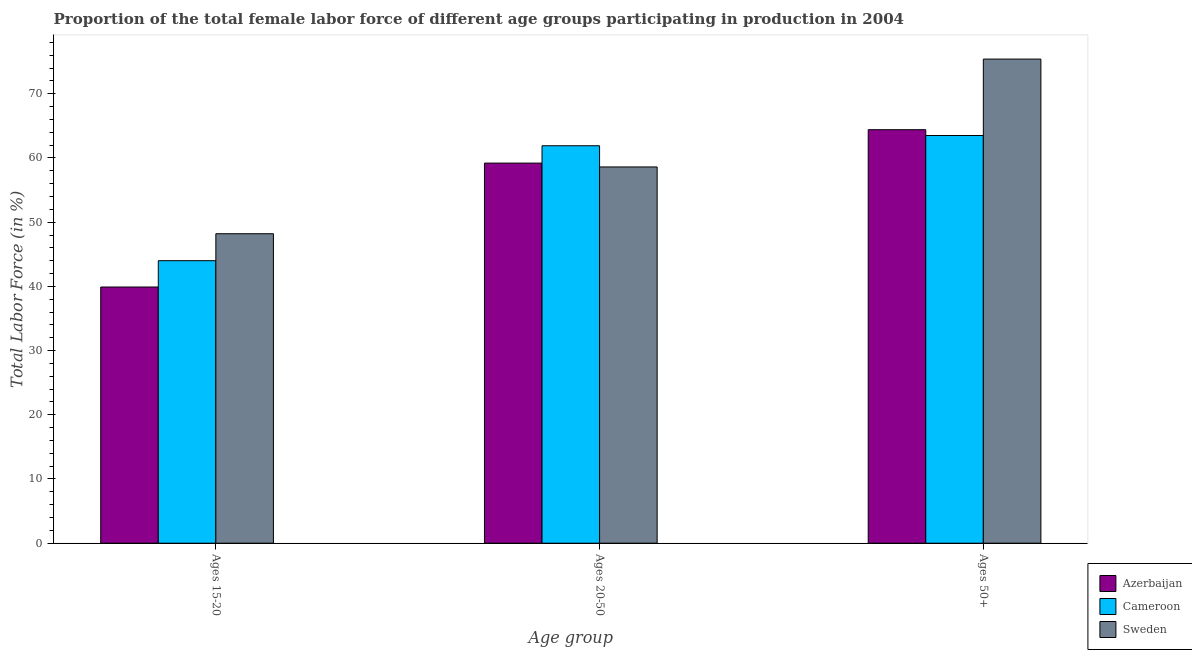What is the label of the 1st group of bars from the left?
Your response must be concise. Ages 15-20. What is the percentage of female labor force above age 50 in Sweden?
Ensure brevity in your answer.  75.4. Across all countries, what is the maximum percentage of female labor force within the age group 20-50?
Your answer should be compact. 61.9. Across all countries, what is the minimum percentage of female labor force within the age group 15-20?
Provide a succinct answer. 39.9. In which country was the percentage of female labor force above age 50 minimum?
Offer a terse response. Cameroon. What is the total percentage of female labor force within the age group 20-50 in the graph?
Your response must be concise. 179.7. What is the difference between the percentage of female labor force within the age group 20-50 in Cameroon and that in Azerbaijan?
Your answer should be very brief. 2.7. What is the average percentage of female labor force above age 50 per country?
Your answer should be very brief. 67.77. What is the difference between the percentage of female labor force within the age group 20-50 and percentage of female labor force above age 50 in Azerbaijan?
Your response must be concise. -5.2. What is the ratio of the percentage of female labor force within the age group 15-20 in Sweden to that in Cameroon?
Give a very brief answer. 1.1. Is the percentage of female labor force within the age group 20-50 in Cameroon less than that in Azerbaijan?
Make the answer very short. No. Is the difference between the percentage of female labor force within the age group 15-20 in Sweden and Cameroon greater than the difference between the percentage of female labor force within the age group 20-50 in Sweden and Cameroon?
Keep it short and to the point. Yes. What is the difference between the highest and the second highest percentage of female labor force above age 50?
Provide a short and direct response. 11. What is the difference between the highest and the lowest percentage of female labor force above age 50?
Offer a terse response. 11.9. What does the 2nd bar from the right in Ages 50+ represents?
Your answer should be compact. Cameroon. Is it the case that in every country, the sum of the percentage of female labor force within the age group 15-20 and percentage of female labor force within the age group 20-50 is greater than the percentage of female labor force above age 50?
Provide a succinct answer. Yes. How many bars are there?
Give a very brief answer. 9. Are all the bars in the graph horizontal?
Give a very brief answer. No. How many countries are there in the graph?
Your answer should be very brief. 3. Does the graph contain any zero values?
Your answer should be very brief. No. Where does the legend appear in the graph?
Your answer should be compact. Bottom right. How are the legend labels stacked?
Provide a succinct answer. Vertical. What is the title of the graph?
Keep it short and to the point. Proportion of the total female labor force of different age groups participating in production in 2004. Does "Greece" appear as one of the legend labels in the graph?
Provide a succinct answer. No. What is the label or title of the X-axis?
Your answer should be very brief. Age group. What is the Total Labor Force (in %) of Azerbaijan in Ages 15-20?
Give a very brief answer. 39.9. What is the Total Labor Force (in %) of Sweden in Ages 15-20?
Provide a succinct answer. 48.2. What is the Total Labor Force (in %) in Azerbaijan in Ages 20-50?
Offer a terse response. 59.2. What is the Total Labor Force (in %) in Cameroon in Ages 20-50?
Give a very brief answer. 61.9. What is the Total Labor Force (in %) of Sweden in Ages 20-50?
Offer a terse response. 58.6. What is the Total Labor Force (in %) in Azerbaijan in Ages 50+?
Give a very brief answer. 64.4. What is the Total Labor Force (in %) in Cameroon in Ages 50+?
Offer a terse response. 63.5. What is the Total Labor Force (in %) of Sweden in Ages 50+?
Give a very brief answer. 75.4. Across all Age group, what is the maximum Total Labor Force (in %) in Azerbaijan?
Ensure brevity in your answer.  64.4. Across all Age group, what is the maximum Total Labor Force (in %) in Cameroon?
Make the answer very short. 63.5. Across all Age group, what is the maximum Total Labor Force (in %) in Sweden?
Provide a short and direct response. 75.4. Across all Age group, what is the minimum Total Labor Force (in %) in Azerbaijan?
Offer a very short reply. 39.9. Across all Age group, what is the minimum Total Labor Force (in %) of Sweden?
Offer a terse response. 48.2. What is the total Total Labor Force (in %) of Azerbaijan in the graph?
Provide a succinct answer. 163.5. What is the total Total Labor Force (in %) in Cameroon in the graph?
Provide a short and direct response. 169.4. What is the total Total Labor Force (in %) in Sweden in the graph?
Offer a very short reply. 182.2. What is the difference between the Total Labor Force (in %) of Azerbaijan in Ages 15-20 and that in Ages 20-50?
Provide a short and direct response. -19.3. What is the difference between the Total Labor Force (in %) of Cameroon in Ages 15-20 and that in Ages 20-50?
Keep it short and to the point. -17.9. What is the difference between the Total Labor Force (in %) of Azerbaijan in Ages 15-20 and that in Ages 50+?
Your response must be concise. -24.5. What is the difference between the Total Labor Force (in %) of Cameroon in Ages 15-20 and that in Ages 50+?
Your response must be concise. -19.5. What is the difference between the Total Labor Force (in %) of Sweden in Ages 15-20 and that in Ages 50+?
Give a very brief answer. -27.2. What is the difference between the Total Labor Force (in %) in Cameroon in Ages 20-50 and that in Ages 50+?
Your response must be concise. -1.6. What is the difference between the Total Labor Force (in %) of Sweden in Ages 20-50 and that in Ages 50+?
Offer a terse response. -16.8. What is the difference between the Total Labor Force (in %) of Azerbaijan in Ages 15-20 and the Total Labor Force (in %) of Sweden in Ages 20-50?
Provide a short and direct response. -18.7. What is the difference between the Total Labor Force (in %) of Cameroon in Ages 15-20 and the Total Labor Force (in %) of Sweden in Ages 20-50?
Provide a succinct answer. -14.6. What is the difference between the Total Labor Force (in %) in Azerbaijan in Ages 15-20 and the Total Labor Force (in %) in Cameroon in Ages 50+?
Ensure brevity in your answer.  -23.6. What is the difference between the Total Labor Force (in %) of Azerbaijan in Ages 15-20 and the Total Labor Force (in %) of Sweden in Ages 50+?
Your answer should be compact. -35.5. What is the difference between the Total Labor Force (in %) in Cameroon in Ages 15-20 and the Total Labor Force (in %) in Sweden in Ages 50+?
Give a very brief answer. -31.4. What is the difference between the Total Labor Force (in %) in Azerbaijan in Ages 20-50 and the Total Labor Force (in %) in Cameroon in Ages 50+?
Make the answer very short. -4.3. What is the difference between the Total Labor Force (in %) of Azerbaijan in Ages 20-50 and the Total Labor Force (in %) of Sweden in Ages 50+?
Offer a very short reply. -16.2. What is the difference between the Total Labor Force (in %) in Cameroon in Ages 20-50 and the Total Labor Force (in %) in Sweden in Ages 50+?
Offer a terse response. -13.5. What is the average Total Labor Force (in %) of Azerbaijan per Age group?
Give a very brief answer. 54.5. What is the average Total Labor Force (in %) in Cameroon per Age group?
Provide a succinct answer. 56.47. What is the average Total Labor Force (in %) in Sweden per Age group?
Your answer should be very brief. 60.73. What is the difference between the Total Labor Force (in %) in Azerbaijan and Total Labor Force (in %) in Sweden in Ages 15-20?
Offer a terse response. -8.3. What is the difference between the Total Labor Force (in %) in Cameroon and Total Labor Force (in %) in Sweden in Ages 15-20?
Provide a succinct answer. -4.2. What is the difference between the Total Labor Force (in %) of Azerbaijan and Total Labor Force (in %) of Sweden in Ages 20-50?
Provide a succinct answer. 0.6. What is the difference between the Total Labor Force (in %) of Azerbaijan and Total Labor Force (in %) of Sweden in Ages 50+?
Offer a terse response. -11. What is the ratio of the Total Labor Force (in %) of Azerbaijan in Ages 15-20 to that in Ages 20-50?
Give a very brief answer. 0.67. What is the ratio of the Total Labor Force (in %) of Cameroon in Ages 15-20 to that in Ages 20-50?
Offer a terse response. 0.71. What is the ratio of the Total Labor Force (in %) in Sweden in Ages 15-20 to that in Ages 20-50?
Make the answer very short. 0.82. What is the ratio of the Total Labor Force (in %) of Azerbaijan in Ages 15-20 to that in Ages 50+?
Offer a terse response. 0.62. What is the ratio of the Total Labor Force (in %) of Cameroon in Ages 15-20 to that in Ages 50+?
Provide a short and direct response. 0.69. What is the ratio of the Total Labor Force (in %) in Sweden in Ages 15-20 to that in Ages 50+?
Ensure brevity in your answer.  0.64. What is the ratio of the Total Labor Force (in %) of Azerbaijan in Ages 20-50 to that in Ages 50+?
Make the answer very short. 0.92. What is the ratio of the Total Labor Force (in %) of Cameroon in Ages 20-50 to that in Ages 50+?
Offer a very short reply. 0.97. What is the ratio of the Total Labor Force (in %) in Sweden in Ages 20-50 to that in Ages 50+?
Offer a very short reply. 0.78. What is the difference between the highest and the second highest Total Labor Force (in %) of Azerbaijan?
Your response must be concise. 5.2. What is the difference between the highest and the second highest Total Labor Force (in %) of Sweden?
Provide a succinct answer. 16.8. What is the difference between the highest and the lowest Total Labor Force (in %) of Cameroon?
Your answer should be very brief. 19.5. What is the difference between the highest and the lowest Total Labor Force (in %) in Sweden?
Provide a succinct answer. 27.2. 